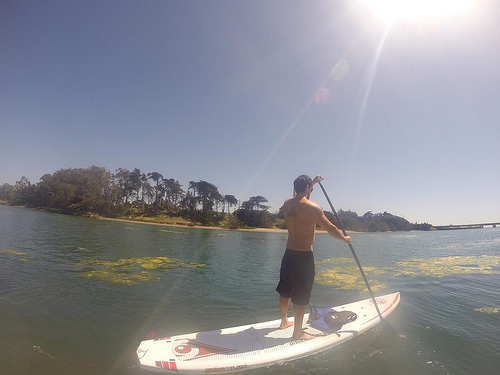<image>
Is there a surfboard next to the surfer? No. The surfboard is not positioned next to the surfer. They are located in different areas of the scene. 